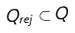<formula> <loc_0><loc_0><loc_500><loc_500>Q _ { r e j } \subset Q</formula> 